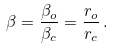Convert formula to latex. <formula><loc_0><loc_0><loc_500><loc_500>\beta = \frac { \beta _ { o } } { \beta _ { c } } = \frac { r _ { o } } { r _ { c } } \, .</formula> 